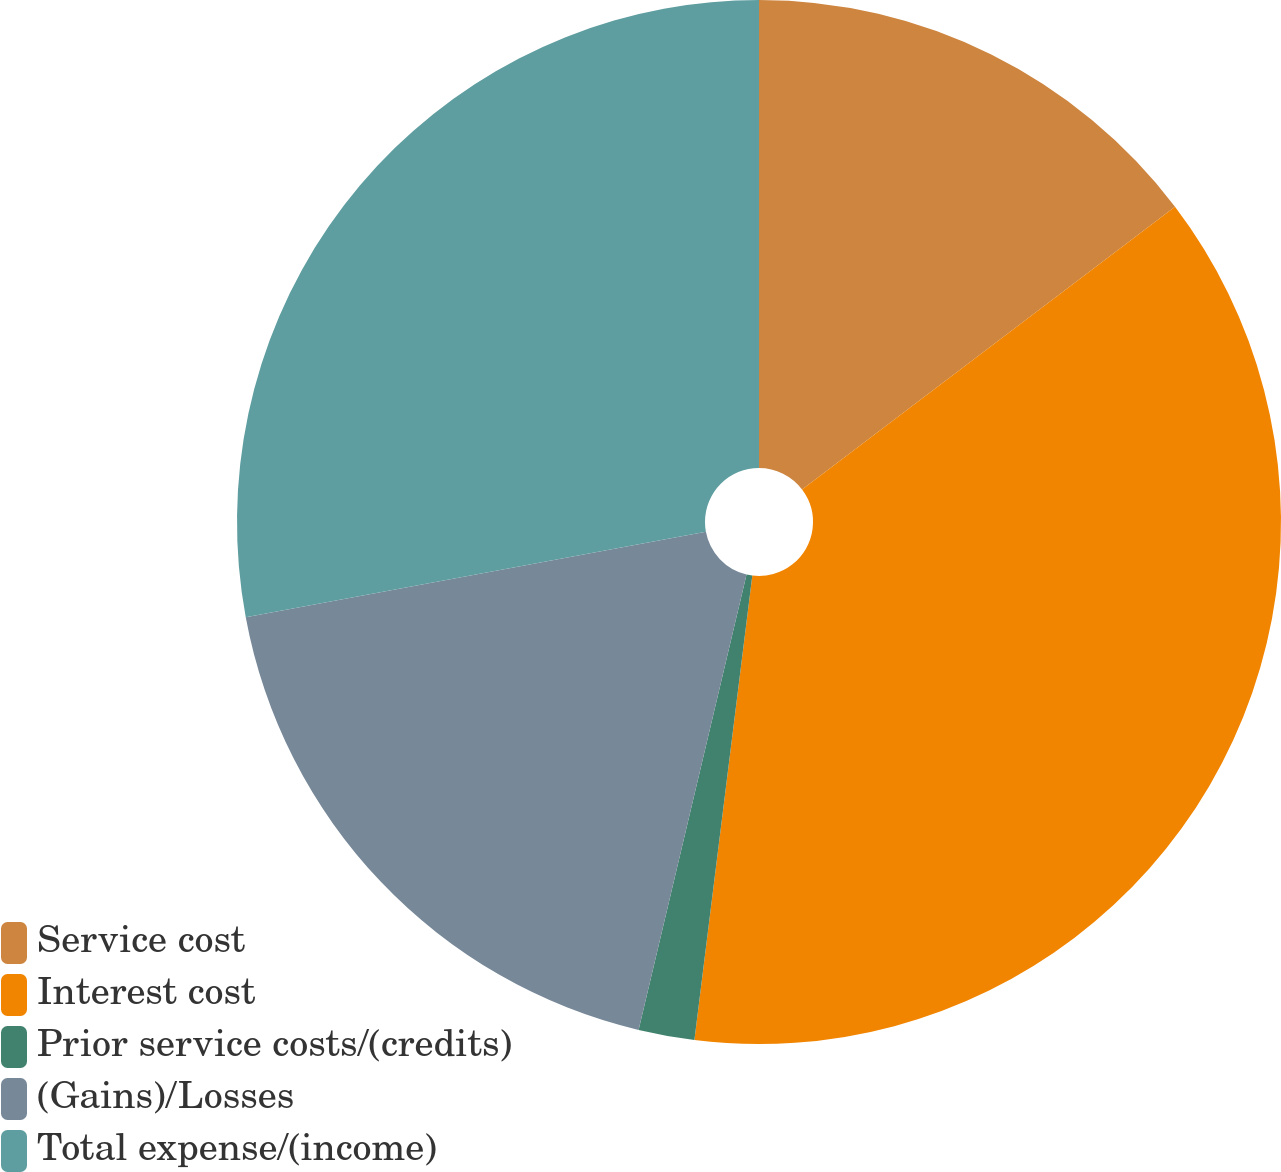Convert chart. <chart><loc_0><loc_0><loc_500><loc_500><pie_chart><fcel>Service cost<fcel>Interest cost<fcel>Prior service costs/(credits)<fcel>(Gains)/Losses<fcel>Total expense/(income)<nl><fcel>14.68%<fcel>37.3%<fcel>1.73%<fcel>18.38%<fcel>27.92%<nl></chart> 